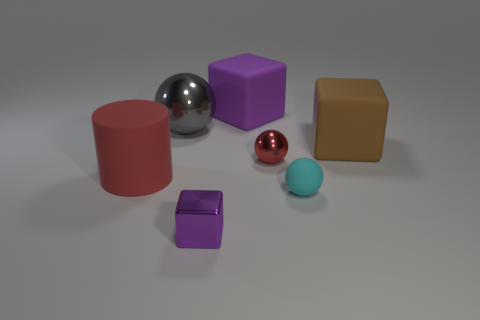Can you describe the shapes and colors of the objects in the image? Certainly, there is a variety of shapes and colors. We have two spheres, large and small, colored silver and red respectively. A large blue cube, and a large red cylinder, both with matte finishes. There's also a smaller brown cube, a smaller purple cube, and a tiny violet rectangular prism. The smaller blue ball has a smooth surface but isn't as reflective as the silver and red spheres. 